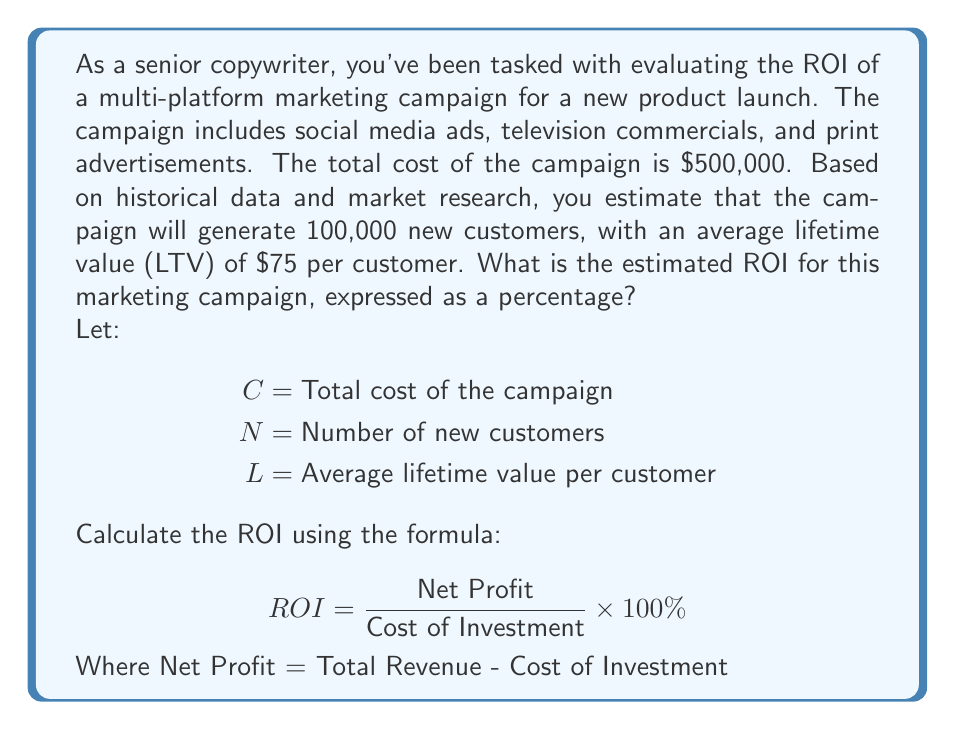Could you help me with this problem? To solve this problem, we'll follow these steps:

1. Calculate the total revenue generated by the campaign:
   Total Revenue = Number of new customers × Average lifetime value per customer
   $$ \text{Total Revenue} = N \times L = 100,000 \times \$75 = \$7,500,000 $$

2. Calculate the net profit:
   Net Profit = Total Revenue - Cost of Investment
   $$ \text{Net Profit} = \$7,500,000 - \$500,000 = \$7,000,000 $$

3. Apply the ROI formula:
   $$ ROI = \frac{\text{Net Profit}}{\text{Cost of Investment}} \times 100\% $$
   $$ ROI = \frac{\$7,000,000}{\$500,000} \times 100\% $$
   $$ ROI = 14 \times 100\% = 1400\% $$

The calculation shows that for every dollar invested in the marketing campaign, the company expects to generate $14 in net profit, resulting in an ROI of 1400%.
Answer: The estimated ROI for the multi-platform marketing campaign is 1400%. 